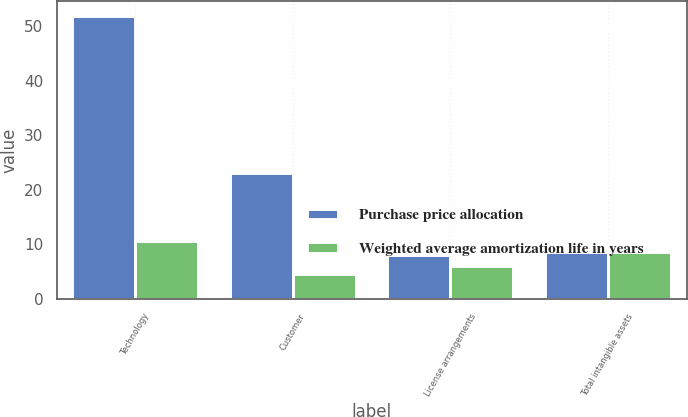Convert chart to OTSL. <chart><loc_0><loc_0><loc_500><loc_500><stacked_bar_chart><ecel><fcel>Technology<fcel>Customer<fcel>License arrangements<fcel>Total intangible assets<nl><fcel>Purchase price allocation<fcel>52<fcel>23<fcel>8<fcel>8.5<nl><fcel>Weighted average amortization life in years<fcel>10.6<fcel>4.5<fcel>6<fcel>8.5<nl></chart> 